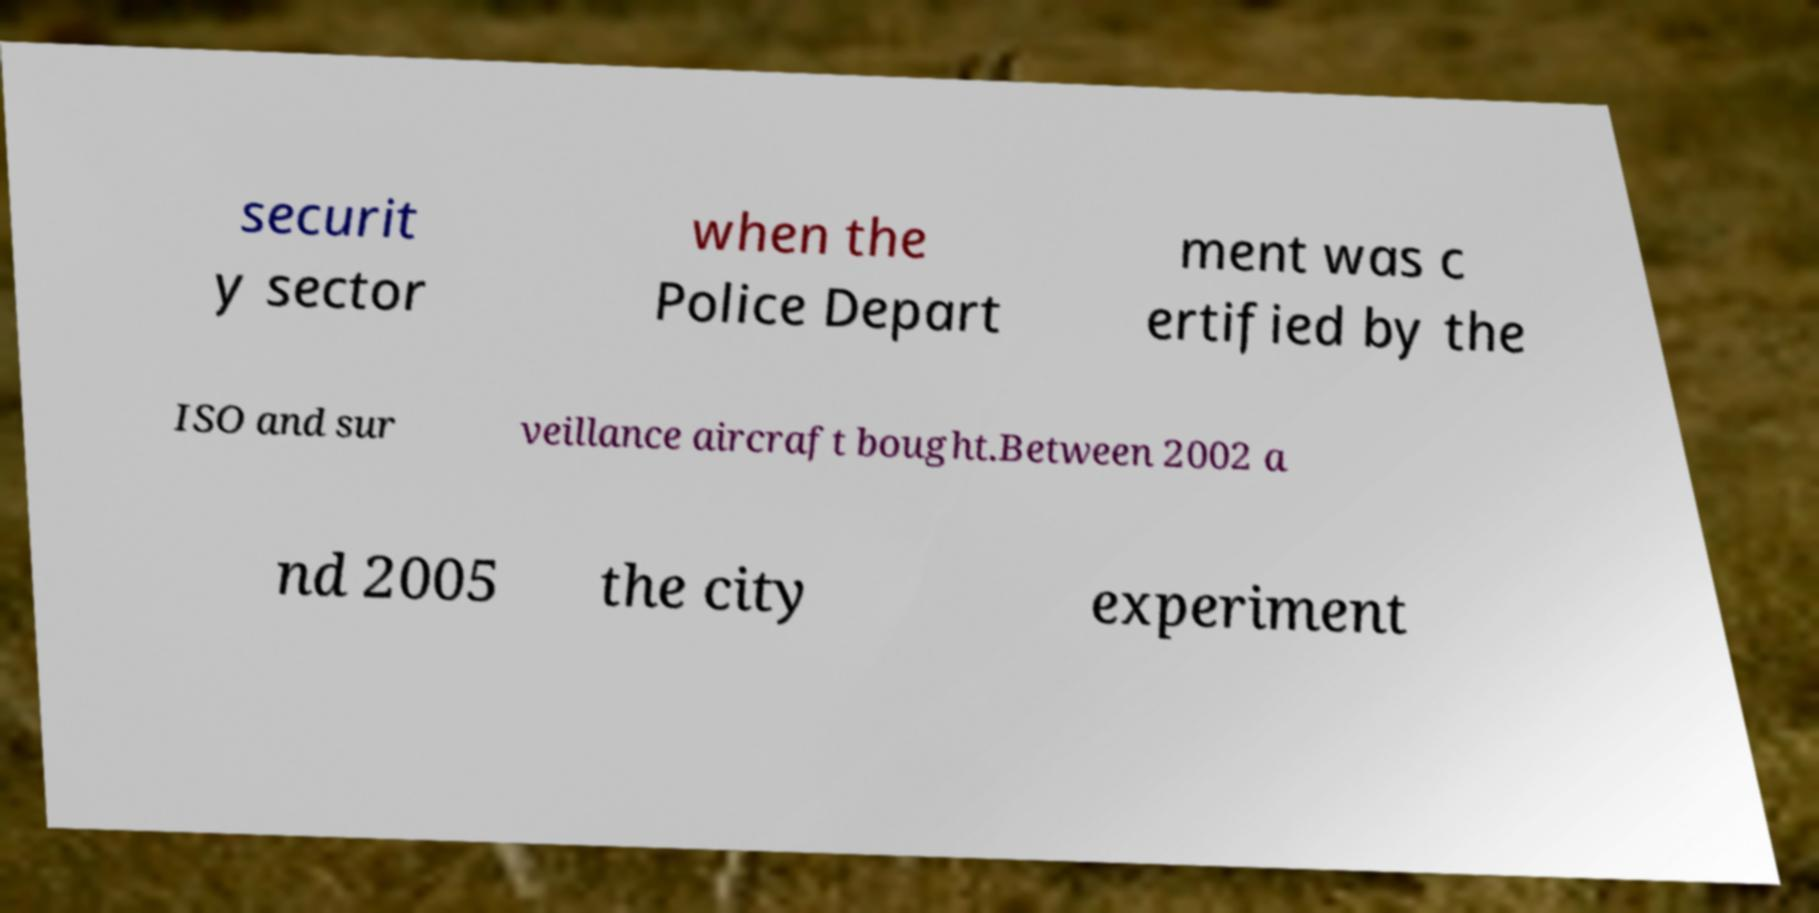There's text embedded in this image that I need extracted. Can you transcribe it verbatim? securit y sector when the Police Depart ment was c ertified by the ISO and sur veillance aircraft bought.Between 2002 a nd 2005 the city experiment 